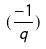<formula> <loc_0><loc_0><loc_500><loc_500>( \frac { - 1 } { q } )</formula> 